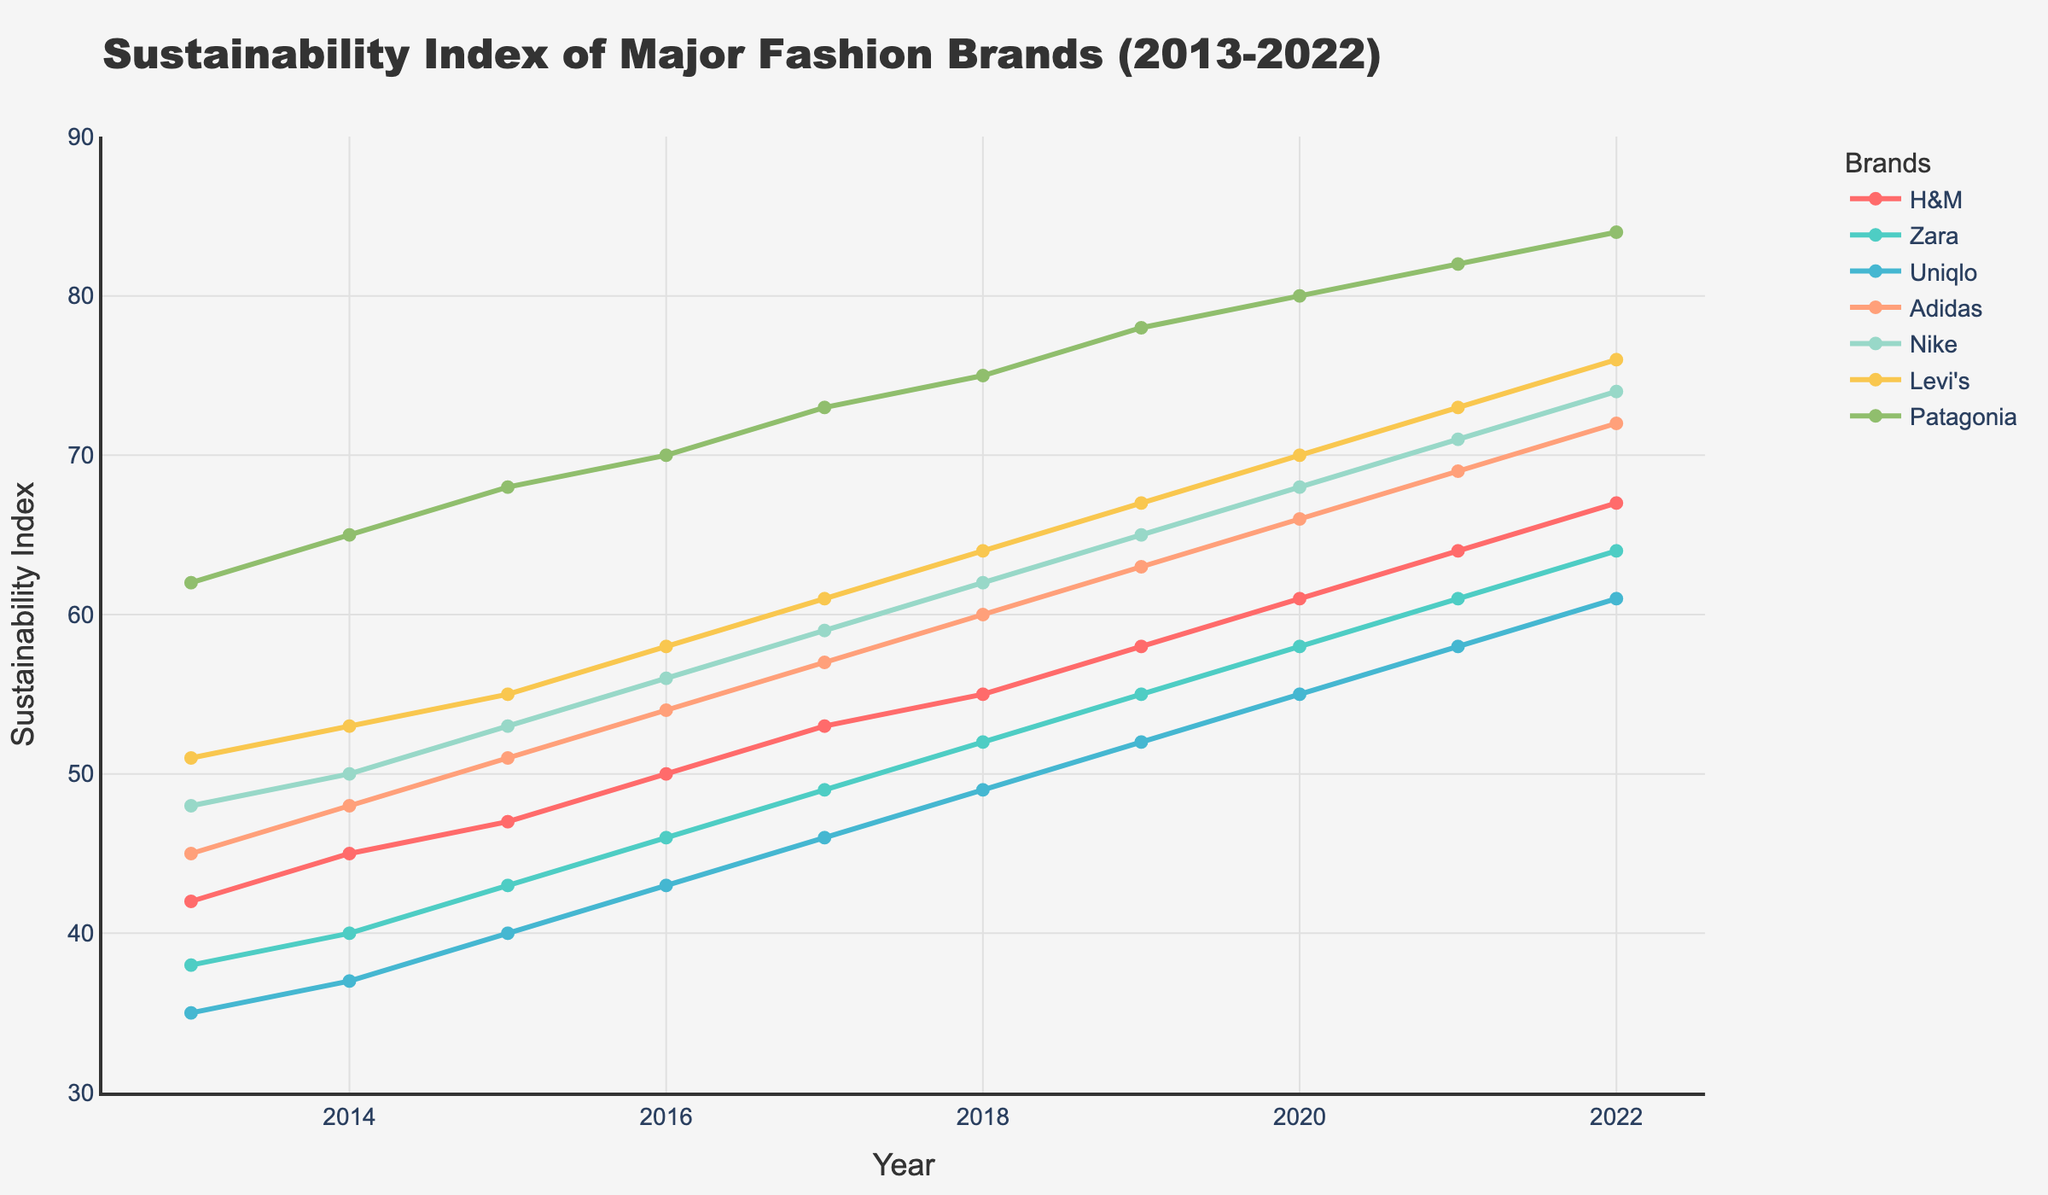Which fashion brand had the highest sustainability index in 2022? The plotted lines show that Patagonia had the highest index in 2022.
Answer: Patagonia How much did H&M's sustainability index increase from 2013 to 2022? H&M's index increased from 42 in 2013 to 67 in 2022. The difference is 67 - 42.
Answer: 25 Which two brands had the closest sustainability index values in 2015 and what were those values? In 2015, the sustainability indices were: H&M (47), Zara (43), Uniqlo (40), Adidas (51), Nike (53), Levi's (55), Patagonia (68). Zara and Uniqlo had values of 43 and 40, respectively.
Answer: Zara (43) and Uniqlo (40) Between 2016 and 2020, which brand showed the most consistent yearly improvement in its sustainability index? Patagonia consistently improved every year from 70 in 2016 to 80 in 2020 without any fluctuations.
Answer: Patagonia By how much did Nike's sustainability index exceed Zara's in the year 2022? In 2022, Nike's index was 74, and Zara's was 64. The difference is 74 - 64.
Answer: 10 What is the average sustainability index of Adidas over the decade? Add Adidas's values from 2013 to 2022 and divide by 10: (45 + 48 + 51 + 54 + 57 + 60 + 63 + 66 + 69 + 72) / 10 = 585 / 10.
Answer: 58.5 Which brand had the greatest increase in sustainability index between the years 2015 and 2018? Calculating the increases: H&M (55-47=8), Zara (52-43=9), Uniqlo (49-40=9), Adidas (60-51=9), Nike (62-53=9), Levi's (64-55=9), Patagonia (75-68=7). Zara, Uniqlo, Adidas, and Levi's had the highest increase of 9.
Answer: Zara, Uniqlo, Adidas, and Levi's Which two brands crossed each other's sustainability index path during the decade, indicating a change in their relative rankings? By observing the plot, Nike (blue) and Levi's (orange) surpassed each other around 2016.
Answer: Nike and Levi's From the data, which brand can be inferred to have the highest rate of sustainability improvement, and what visual clue indicates this? Patagonia shows the highest rate of improvement, indicated by the steepest incline in its plotted line from 2013 to 2022.
Answer: Patagonia 